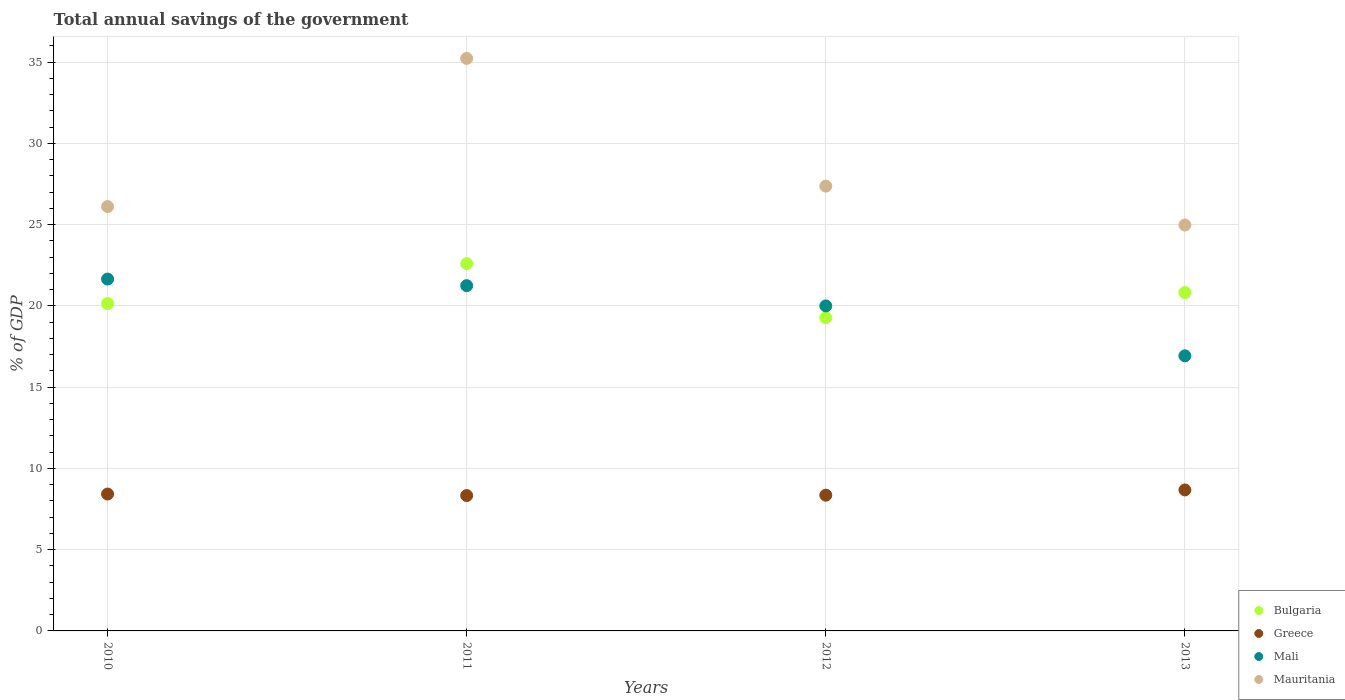What is the total annual savings of the government in Mali in 2013?
Provide a short and direct response. 16.93. Across all years, what is the maximum total annual savings of the government in Mali?
Your response must be concise. 21.65. Across all years, what is the minimum total annual savings of the government in Mali?
Keep it short and to the point. 16.93. In which year was the total annual savings of the government in Mauritania maximum?
Your answer should be very brief. 2011. What is the total total annual savings of the government in Mali in the graph?
Offer a terse response. 79.84. What is the difference between the total annual savings of the government in Mali in 2012 and that in 2013?
Give a very brief answer. 3.07. What is the difference between the total annual savings of the government in Mali in 2011 and the total annual savings of the government in Bulgaria in 2010?
Offer a terse response. 1.1. What is the average total annual savings of the government in Greece per year?
Offer a very short reply. 8.45. In the year 2012, what is the difference between the total annual savings of the government in Mauritania and total annual savings of the government in Mali?
Provide a short and direct response. 7.37. In how many years, is the total annual savings of the government in Mauritania greater than 3 %?
Provide a succinct answer. 4. What is the ratio of the total annual savings of the government in Mali in 2011 to that in 2013?
Provide a short and direct response. 1.26. Is the total annual savings of the government in Greece in 2011 less than that in 2013?
Your answer should be very brief. Yes. Is the difference between the total annual savings of the government in Mauritania in 2010 and 2011 greater than the difference between the total annual savings of the government in Mali in 2010 and 2011?
Give a very brief answer. No. What is the difference between the highest and the second highest total annual savings of the government in Mauritania?
Keep it short and to the point. 7.86. What is the difference between the highest and the lowest total annual savings of the government in Bulgaria?
Ensure brevity in your answer.  3.32. Is it the case that in every year, the sum of the total annual savings of the government in Greece and total annual savings of the government in Mauritania  is greater than the sum of total annual savings of the government in Mali and total annual savings of the government in Bulgaria?
Your answer should be very brief. No. Is it the case that in every year, the sum of the total annual savings of the government in Greece and total annual savings of the government in Mali  is greater than the total annual savings of the government in Mauritania?
Provide a short and direct response. No. Is the total annual savings of the government in Mauritania strictly greater than the total annual savings of the government in Bulgaria over the years?
Offer a terse response. Yes. Is the total annual savings of the government in Mali strictly less than the total annual savings of the government in Bulgaria over the years?
Make the answer very short. No. What is the difference between two consecutive major ticks on the Y-axis?
Ensure brevity in your answer.  5. Does the graph contain any zero values?
Ensure brevity in your answer.  No. Does the graph contain grids?
Offer a very short reply. Yes. How many legend labels are there?
Provide a short and direct response. 4. How are the legend labels stacked?
Offer a terse response. Vertical. What is the title of the graph?
Your answer should be very brief. Total annual savings of the government. What is the label or title of the X-axis?
Ensure brevity in your answer.  Years. What is the label or title of the Y-axis?
Provide a succinct answer. % of GDP. What is the % of GDP of Bulgaria in 2010?
Ensure brevity in your answer.  20.15. What is the % of GDP of Greece in 2010?
Offer a terse response. 8.42. What is the % of GDP in Mali in 2010?
Offer a very short reply. 21.65. What is the % of GDP of Mauritania in 2010?
Keep it short and to the point. 26.12. What is the % of GDP in Bulgaria in 2011?
Make the answer very short. 22.6. What is the % of GDP in Greece in 2011?
Provide a succinct answer. 8.33. What is the % of GDP in Mali in 2011?
Keep it short and to the point. 21.25. What is the % of GDP in Mauritania in 2011?
Make the answer very short. 35.23. What is the % of GDP in Bulgaria in 2012?
Your answer should be very brief. 19.28. What is the % of GDP in Greece in 2012?
Provide a short and direct response. 8.35. What is the % of GDP of Mali in 2012?
Your answer should be compact. 20. What is the % of GDP in Mauritania in 2012?
Ensure brevity in your answer.  27.37. What is the % of GDP of Bulgaria in 2013?
Your answer should be very brief. 20.82. What is the % of GDP of Greece in 2013?
Your answer should be compact. 8.68. What is the % of GDP of Mali in 2013?
Your answer should be compact. 16.93. What is the % of GDP of Mauritania in 2013?
Offer a terse response. 24.98. Across all years, what is the maximum % of GDP in Bulgaria?
Your answer should be compact. 22.6. Across all years, what is the maximum % of GDP of Greece?
Provide a succinct answer. 8.68. Across all years, what is the maximum % of GDP in Mali?
Offer a very short reply. 21.65. Across all years, what is the maximum % of GDP of Mauritania?
Keep it short and to the point. 35.23. Across all years, what is the minimum % of GDP of Bulgaria?
Your answer should be compact. 19.28. Across all years, what is the minimum % of GDP of Greece?
Keep it short and to the point. 8.33. Across all years, what is the minimum % of GDP in Mali?
Offer a very short reply. 16.93. Across all years, what is the minimum % of GDP in Mauritania?
Provide a short and direct response. 24.98. What is the total % of GDP in Bulgaria in the graph?
Your answer should be very brief. 82.85. What is the total % of GDP of Greece in the graph?
Provide a succinct answer. 33.78. What is the total % of GDP of Mali in the graph?
Offer a very short reply. 79.84. What is the total % of GDP of Mauritania in the graph?
Give a very brief answer. 113.7. What is the difference between the % of GDP of Bulgaria in 2010 and that in 2011?
Your answer should be very brief. -2.46. What is the difference between the % of GDP in Greece in 2010 and that in 2011?
Give a very brief answer. 0.09. What is the difference between the % of GDP of Mali in 2010 and that in 2011?
Offer a very short reply. 0.41. What is the difference between the % of GDP in Mauritania in 2010 and that in 2011?
Make the answer very short. -9.11. What is the difference between the % of GDP in Bulgaria in 2010 and that in 2012?
Your answer should be very brief. 0.87. What is the difference between the % of GDP in Greece in 2010 and that in 2012?
Keep it short and to the point. 0.07. What is the difference between the % of GDP in Mali in 2010 and that in 2012?
Provide a succinct answer. 1.65. What is the difference between the % of GDP of Mauritania in 2010 and that in 2012?
Give a very brief answer. -1.26. What is the difference between the % of GDP of Bulgaria in 2010 and that in 2013?
Keep it short and to the point. -0.68. What is the difference between the % of GDP of Greece in 2010 and that in 2013?
Your response must be concise. -0.25. What is the difference between the % of GDP of Mali in 2010 and that in 2013?
Offer a terse response. 4.72. What is the difference between the % of GDP of Mauritania in 2010 and that in 2013?
Your answer should be very brief. 1.14. What is the difference between the % of GDP in Bulgaria in 2011 and that in 2012?
Your response must be concise. 3.32. What is the difference between the % of GDP of Greece in 2011 and that in 2012?
Make the answer very short. -0.02. What is the difference between the % of GDP of Mali in 2011 and that in 2012?
Provide a succinct answer. 1.25. What is the difference between the % of GDP of Mauritania in 2011 and that in 2012?
Ensure brevity in your answer.  7.86. What is the difference between the % of GDP of Bulgaria in 2011 and that in 2013?
Ensure brevity in your answer.  1.78. What is the difference between the % of GDP of Greece in 2011 and that in 2013?
Provide a short and direct response. -0.35. What is the difference between the % of GDP in Mali in 2011 and that in 2013?
Make the answer very short. 4.32. What is the difference between the % of GDP of Mauritania in 2011 and that in 2013?
Keep it short and to the point. 10.25. What is the difference between the % of GDP of Bulgaria in 2012 and that in 2013?
Provide a short and direct response. -1.54. What is the difference between the % of GDP of Greece in 2012 and that in 2013?
Give a very brief answer. -0.32. What is the difference between the % of GDP in Mali in 2012 and that in 2013?
Your answer should be compact. 3.07. What is the difference between the % of GDP of Mauritania in 2012 and that in 2013?
Provide a succinct answer. 2.39. What is the difference between the % of GDP of Bulgaria in 2010 and the % of GDP of Greece in 2011?
Your answer should be very brief. 11.81. What is the difference between the % of GDP in Bulgaria in 2010 and the % of GDP in Mali in 2011?
Your answer should be compact. -1.1. What is the difference between the % of GDP in Bulgaria in 2010 and the % of GDP in Mauritania in 2011?
Provide a short and direct response. -15.09. What is the difference between the % of GDP in Greece in 2010 and the % of GDP in Mali in 2011?
Ensure brevity in your answer.  -12.83. What is the difference between the % of GDP of Greece in 2010 and the % of GDP of Mauritania in 2011?
Ensure brevity in your answer.  -26.81. What is the difference between the % of GDP in Mali in 2010 and the % of GDP in Mauritania in 2011?
Make the answer very short. -13.58. What is the difference between the % of GDP of Bulgaria in 2010 and the % of GDP of Greece in 2012?
Offer a terse response. 11.79. What is the difference between the % of GDP in Bulgaria in 2010 and the % of GDP in Mali in 2012?
Give a very brief answer. 0.14. What is the difference between the % of GDP of Bulgaria in 2010 and the % of GDP of Mauritania in 2012?
Your answer should be compact. -7.23. What is the difference between the % of GDP in Greece in 2010 and the % of GDP in Mali in 2012?
Offer a terse response. -11.58. What is the difference between the % of GDP of Greece in 2010 and the % of GDP of Mauritania in 2012?
Provide a short and direct response. -18.95. What is the difference between the % of GDP in Mali in 2010 and the % of GDP in Mauritania in 2012?
Make the answer very short. -5.72. What is the difference between the % of GDP of Bulgaria in 2010 and the % of GDP of Greece in 2013?
Give a very brief answer. 11.47. What is the difference between the % of GDP of Bulgaria in 2010 and the % of GDP of Mali in 2013?
Offer a very short reply. 3.21. What is the difference between the % of GDP in Bulgaria in 2010 and the % of GDP in Mauritania in 2013?
Offer a very short reply. -4.83. What is the difference between the % of GDP in Greece in 2010 and the % of GDP in Mali in 2013?
Make the answer very short. -8.51. What is the difference between the % of GDP in Greece in 2010 and the % of GDP in Mauritania in 2013?
Give a very brief answer. -16.56. What is the difference between the % of GDP of Mali in 2010 and the % of GDP of Mauritania in 2013?
Give a very brief answer. -3.32. What is the difference between the % of GDP of Bulgaria in 2011 and the % of GDP of Greece in 2012?
Provide a short and direct response. 14.25. What is the difference between the % of GDP of Bulgaria in 2011 and the % of GDP of Mali in 2012?
Give a very brief answer. 2.6. What is the difference between the % of GDP in Bulgaria in 2011 and the % of GDP in Mauritania in 2012?
Provide a succinct answer. -4.77. What is the difference between the % of GDP of Greece in 2011 and the % of GDP of Mali in 2012?
Make the answer very short. -11.67. What is the difference between the % of GDP in Greece in 2011 and the % of GDP in Mauritania in 2012?
Your answer should be very brief. -19.04. What is the difference between the % of GDP of Mali in 2011 and the % of GDP of Mauritania in 2012?
Keep it short and to the point. -6.12. What is the difference between the % of GDP in Bulgaria in 2011 and the % of GDP in Greece in 2013?
Your answer should be compact. 13.93. What is the difference between the % of GDP in Bulgaria in 2011 and the % of GDP in Mali in 2013?
Ensure brevity in your answer.  5.67. What is the difference between the % of GDP in Bulgaria in 2011 and the % of GDP in Mauritania in 2013?
Ensure brevity in your answer.  -2.38. What is the difference between the % of GDP of Greece in 2011 and the % of GDP of Mali in 2013?
Offer a terse response. -8.6. What is the difference between the % of GDP in Greece in 2011 and the % of GDP in Mauritania in 2013?
Give a very brief answer. -16.65. What is the difference between the % of GDP of Mali in 2011 and the % of GDP of Mauritania in 2013?
Ensure brevity in your answer.  -3.73. What is the difference between the % of GDP in Bulgaria in 2012 and the % of GDP in Greece in 2013?
Make the answer very short. 10.6. What is the difference between the % of GDP in Bulgaria in 2012 and the % of GDP in Mali in 2013?
Offer a terse response. 2.35. What is the difference between the % of GDP of Bulgaria in 2012 and the % of GDP of Mauritania in 2013?
Offer a terse response. -5.7. What is the difference between the % of GDP in Greece in 2012 and the % of GDP in Mali in 2013?
Provide a short and direct response. -8.58. What is the difference between the % of GDP of Greece in 2012 and the % of GDP of Mauritania in 2013?
Ensure brevity in your answer.  -16.63. What is the difference between the % of GDP in Mali in 2012 and the % of GDP in Mauritania in 2013?
Your answer should be very brief. -4.98. What is the average % of GDP of Bulgaria per year?
Offer a very short reply. 20.71. What is the average % of GDP in Greece per year?
Provide a succinct answer. 8.45. What is the average % of GDP of Mali per year?
Provide a succinct answer. 19.96. What is the average % of GDP in Mauritania per year?
Provide a succinct answer. 28.43. In the year 2010, what is the difference between the % of GDP of Bulgaria and % of GDP of Greece?
Offer a very short reply. 11.72. In the year 2010, what is the difference between the % of GDP in Bulgaria and % of GDP in Mali?
Provide a short and direct response. -1.51. In the year 2010, what is the difference between the % of GDP in Bulgaria and % of GDP in Mauritania?
Your answer should be compact. -5.97. In the year 2010, what is the difference between the % of GDP in Greece and % of GDP in Mali?
Ensure brevity in your answer.  -13.23. In the year 2010, what is the difference between the % of GDP of Greece and % of GDP of Mauritania?
Keep it short and to the point. -17.69. In the year 2010, what is the difference between the % of GDP of Mali and % of GDP of Mauritania?
Provide a short and direct response. -4.46. In the year 2011, what is the difference between the % of GDP of Bulgaria and % of GDP of Greece?
Your response must be concise. 14.27. In the year 2011, what is the difference between the % of GDP of Bulgaria and % of GDP of Mali?
Your response must be concise. 1.35. In the year 2011, what is the difference between the % of GDP in Bulgaria and % of GDP in Mauritania?
Your answer should be very brief. -12.63. In the year 2011, what is the difference between the % of GDP in Greece and % of GDP in Mali?
Make the answer very short. -12.92. In the year 2011, what is the difference between the % of GDP in Greece and % of GDP in Mauritania?
Provide a succinct answer. -26.9. In the year 2011, what is the difference between the % of GDP in Mali and % of GDP in Mauritania?
Provide a succinct answer. -13.98. In the year 2012, what is the difference between the % of GDP in Bulgaria and % of GDP in Greece?
Keep it short and to the point. 10.93. In the year 2012, what is the difference between the % of GDP of Bulgaria and % of GDP of Mali?
Your answer should be compact. -0.72. In the year 2012, what is the difference between the % of GDP in Bulgaria and % of GDP in Mauritania?
Offer a very short reply. -8.09. In the year 2012, what is the difference between the % of GDP of Greece and % of GDP of Mali?
Provide a succinct answer. -11.65. In the year 2012, what is the difference between the % of GDP in Greece and % of GDP in Mauritania?
Give a very brief answer. -19.02. In the year 2012, what is the difference between the % of GDP of Mali and % of GDP of Mauritania?
Provide a succinct answer. -7.37. In the year 2013, what is the difference between the % of GDP of Bulgaria and % of GDP of Greece?
Make the answer very short. 12.15. In the year 2013, what is the difference between the % of GDP of Bulgaria and % of GDP of Mali?
Keep it short and to the point. 3.89. In the year 2013, what is the difference between the % of GDP in Bulgaria and % of GDP in Mauritania?
Offer a terse response. -4.16. In the year 2013, what is the difference between the % of GDP of Greece and % of GDP of Mali?
Provide a succinct answer. -8.26. In the year 2013, what is the difference between the % of GDP in Greece and % of GDP in Mauritania?
Give a very brief answer. -16.3. In the year 2013, what is the difference between the % of GDP of Mali and % of GDP of Mauritania?
Keep it short and to the point. -8.05. What is the ratio of the % of GDP in Bulgaria in 2010 to that in 2011?
Your answer should be compact. 0.89. What is the ratio of the % of GDP of Greece in 2010 to that in 2011?
Provide a short and direct response. 1.01. What is the ratio of the % of GDP in Mali in 2010 to that in 2011?
Provide a short and direct response. 1.02. What is the ratio of the % of GDP of Mauritania in 2010 to that in 2011?
Ensure brevity in your answer.  0.74. What is the ratio of the % of GDP of Bulgaria in 2010 to that in 2012?
Provide a succinct answer. 1.04. What is the ratio of the % of GDP of Greece in 2010 to that in 2012?
Your response must be concise. 1.01. What is the ratio of the % of GDP in Mali in 2010 to that in 2012?
Provide a succinct answer. 1.08. What is the ratio of the % of GDP of Mauritania in 2010 to that in 2012?
Your answer should be very brief. 0.95. What is the ratio of the % of GDP of Bulgaria in 2010 to that in 2013?
Offer a terse response. 0.97. What is the ratio of the % of GDP of Greece in 2010 to that in 2013?
Give a very brief answer. 0.97. What is the ratio of the % of GDP in Mali in 2010 to that in 2013?
Your answer should be compact. 1.28. What is the ratio of the % of GDP of Mauritania in 2010 to that in 2013?
Make the answer very short. 1.05. What is the ratio of the % of GDP of Bulgaria in 2011 to that in 2012?
Keep it short and to the point. 1.17. What is the ratio of the % of GDP in Mali in 2011 to that in 2012?
Offer a very short reply. 1.06. What is the ratio of the % of GDP of Mauritania in 2011 to that in 2012?
Your response must be concise. 1.29. What is the ratio of the % of GDP in Bulgaria in 2011 to that in 2013?
Offer a terse response. 1.09. What is the ratio of the % of GDP in Greece in 2011 to that in 2013?
Offer a very short reply. 0.96. What is the ratio of the % of GDP of Mali in 2011 to that in 2013?
Keep it short and to the point. 1.25. What is the ratio of the % of GDP in Mauritania in 2011 to that in 2013?
Your response must be concise. 1.41. What is the ratio of the % of GDP in Bulgaria in 2012 to that in 2013?
Ensure brevity in your answer.  0.93. What is the ratio of the % of GDP in Greece in 2012 to that in 2013?
Your answer should be compact. 0.96. What is the ratio of the % of GDP of Mali in 2012 to that in 2013?
Provide a short and direct response. 1.18. What is the ratio of the % of GDP of Mauritania in 2012 to that in 2013?
Your answer should be compact. 1.1. What is the difference between the highest and the second highest % of GDP of Bulgaria?
Offer a terse response. 1.78. What is the difference between the highest and the second highest % of GDP of Greece?
Give a very brief answer. 0.25. What is the difference between the highest and the second highest % of GDP in Mali?
Make the answer very short. 0.41. What is the difference between the highest and the second highest % of GDP in Mauritania?
Your response must be concise. 7.86. What is the difference between the highest and the lowest % of GDP in Bulgaria?
Give a very brief answer. 3.32. What is the difference between the highest and the lowest % of GDP of Greece?
Keep it short and to the point. 0.35. What is the difference between the highest and the lowest % of GDP of Mali?
Your response must be concise. 4.72. What is the difference between the highest and the lowest % of GDP of Mauritania?
Provide a short and direct response. 10.25. 